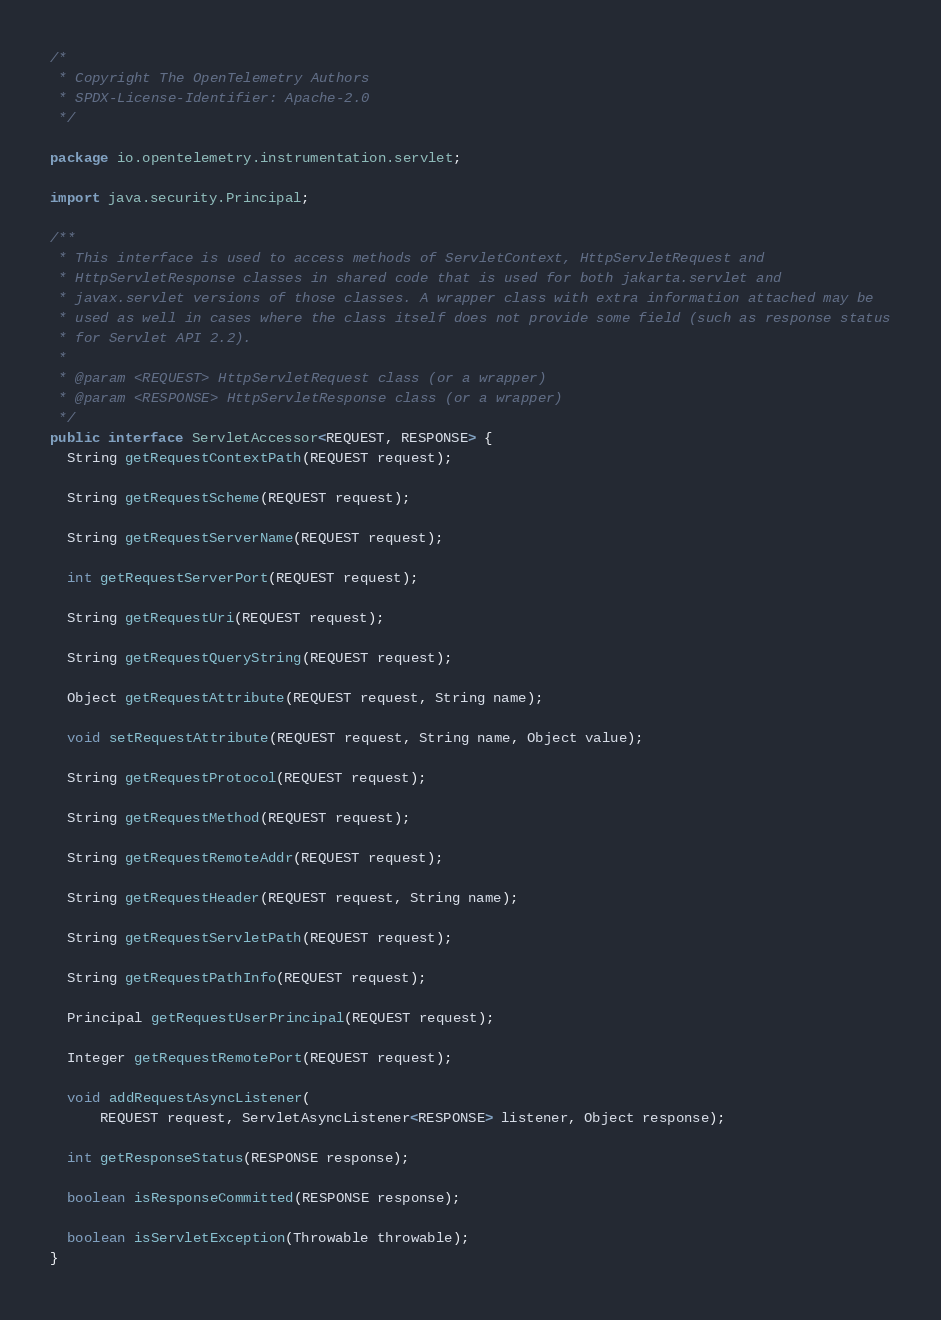Convert code to text. <code><loc_0><loc_0><loc_500><loc_500><_Java_>/*
 * Copyright The OpenTelemetry Authors
 * SPDX-License-Identifier: Apache-2.0
 */

package io.opentelemetry.instrumentation.servlet;

import java.security.Principal;

/**
 * This interface is used to access methods of ServletContext, HttpServletRequest and
 * HttpServletResponse classes in shared code that is used for both jakarta.servlet and
 * javax.servlet versions of those classes. A wrapper class with extra information attached may be
 * used as well in cases where the class itself does not provide some field (such as response status
 * for Servlet API 2.2).
 *
 * @param <REQUEST> HttpServletRequest class (or a wrapper)
 * @param <RESPONSE> HttpServletResponse class (or a wrapper)
 */
public interface ServletAccessor<REQUEST, RESPONSE> {
  String getRequestContextPath(REQUEST request);

  String getRequestScheme(REQUEST request);

  String getRequestServerName(REQUEST request);

  int getRequestServerPort(REQUEST request);

  String getRequestUri(REQUEST request);

  String getRequestQueryString(REQUEST request);

  Object getRequestAttribute(REQUEST request, String name);

  void setRequestAttribute(REQUEST request, String name, Object value);

  String getRequestProtocol(REQUEST request);

  String getRequestMethod(REQUEST request);

  String getRequestRemoteAddr(REQUEST request);

  String getRequestHeader(REQUEST request, String name);

  String getRequestServletPath(REQUEST request);

  String getRequestPathInfo(REQUEST request);

  Principal getRequestUserPrincipal(REQUEST request);

  Integer getRequestRemotePort(REQUEST request);

  void addRequestAsyncListener(
      REQUEST request, ServletAsyncListener<RESPONSE> listener, Object response);

  int getResponseStatus(RESPONSE response);

  boolean isResponseCommitted(RESPONSE response);

  boolean isServletException(Throwable throwable);
}
</code> 